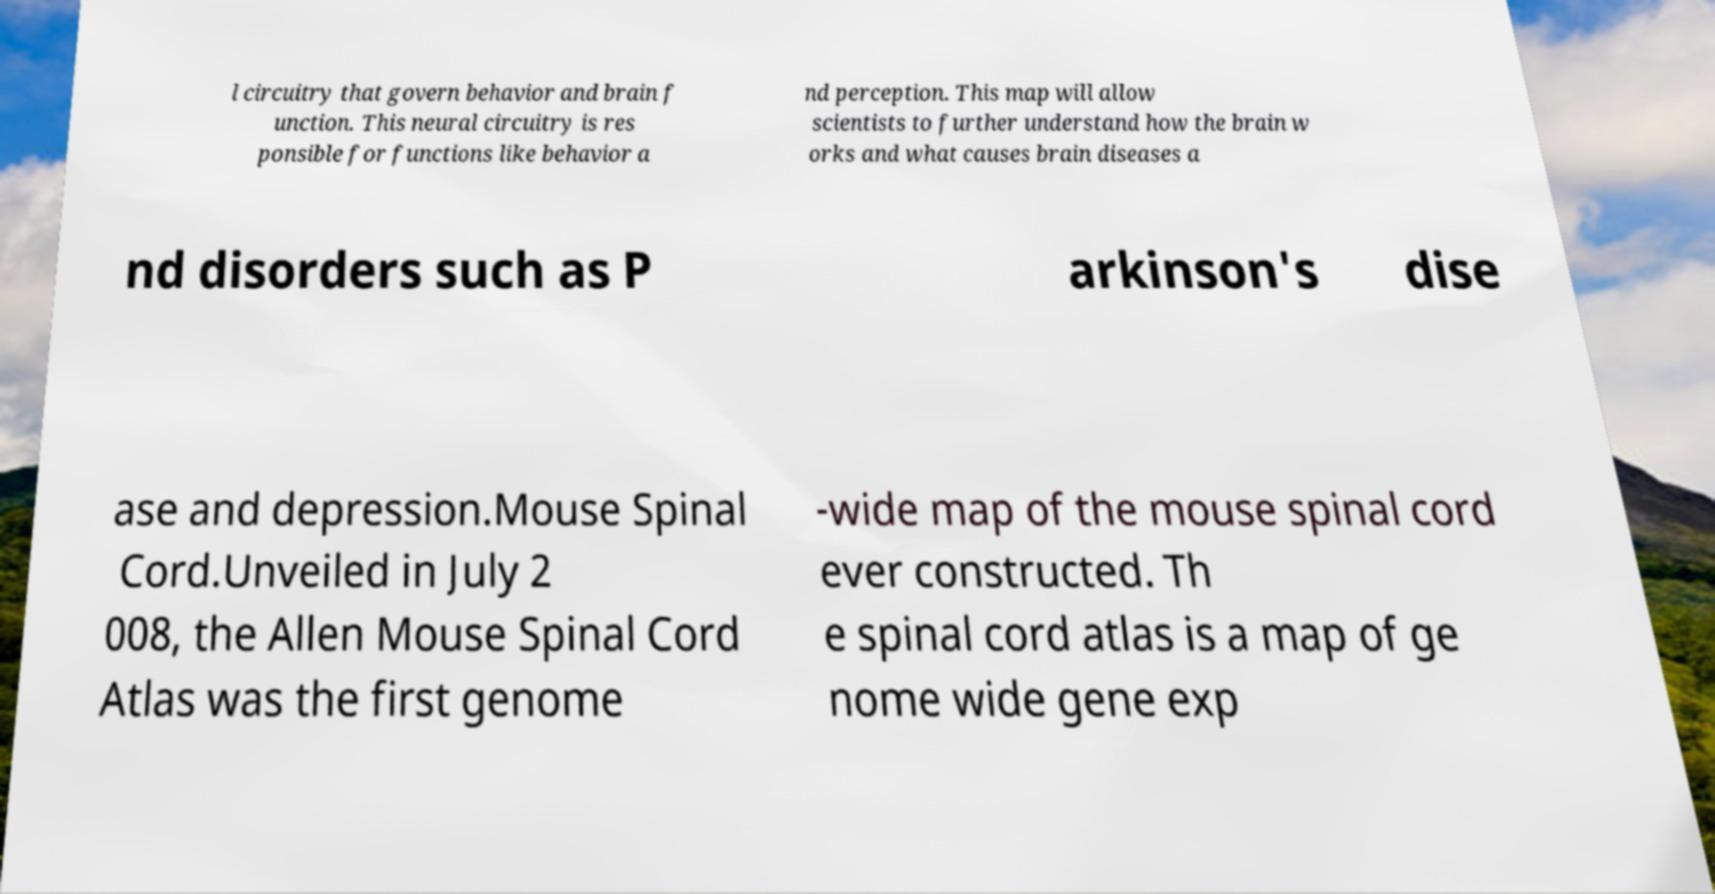What messages or text are displayed in this image? I need them in a readable, typed format. l circuitry that govern behavior and brain f unction. This neural circuitry is res ponsible for functions like behavior a nd perception. This map will allow scientists to further understand how the brain w orks and what causes brain diseases a nd disorders such as P arkinson's dise ase and depression.Mouse Spinal Cord.Unveiled in July 2 008, the Allen Mouse Spinal Cord Atlas was the first genome -wide map of the mouse spinal cord ever constructed. Th e spinal cord atlas is a map of ge nome wide gene exp 